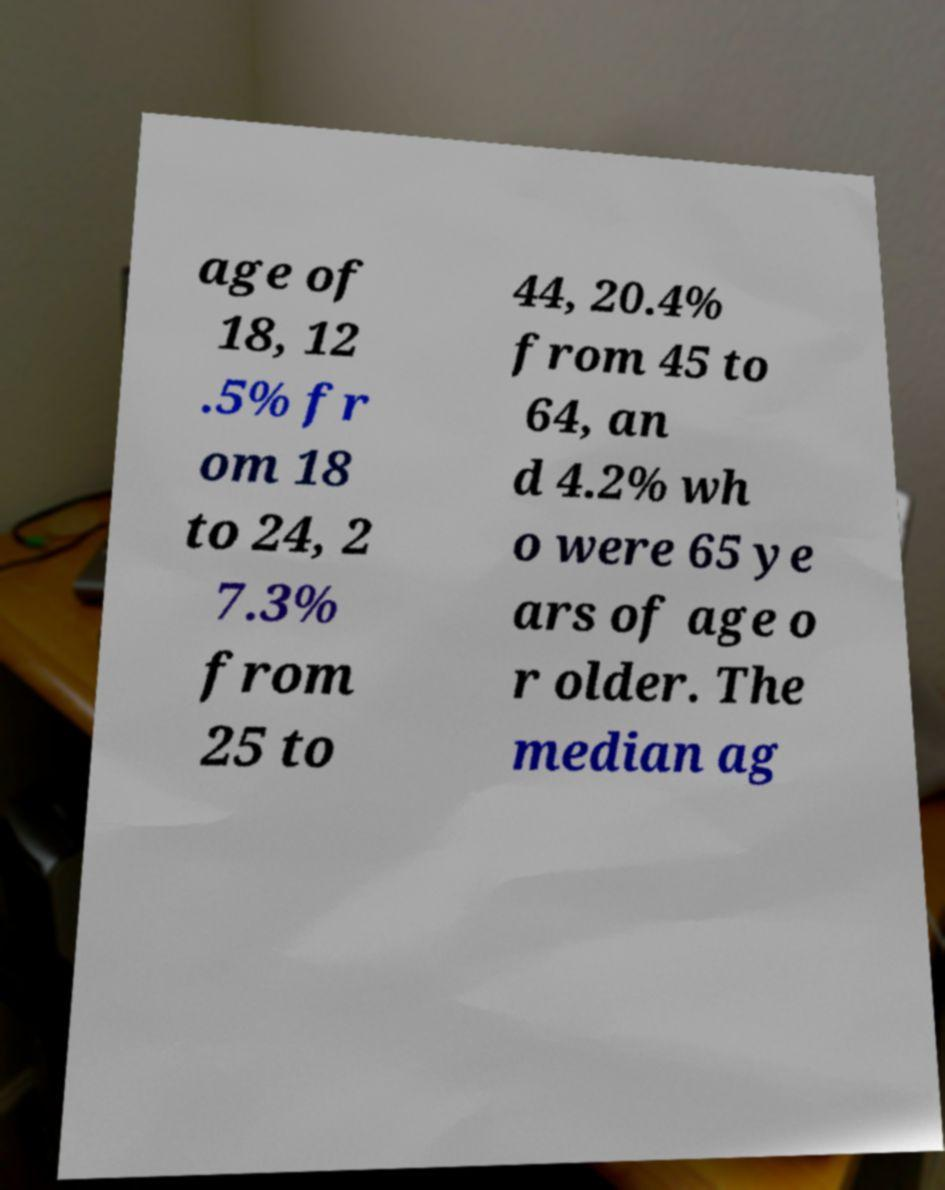There's text embedded in this image that I need extracted. Can you transcribe it verbatim? age of 18, 12 .5% fr om 18 to 24, 2 7.3% from 25 to 44, 20.4% from 45 to 64, an d 4.2% wh o were 65 ye ars of age o r older. The median ag 